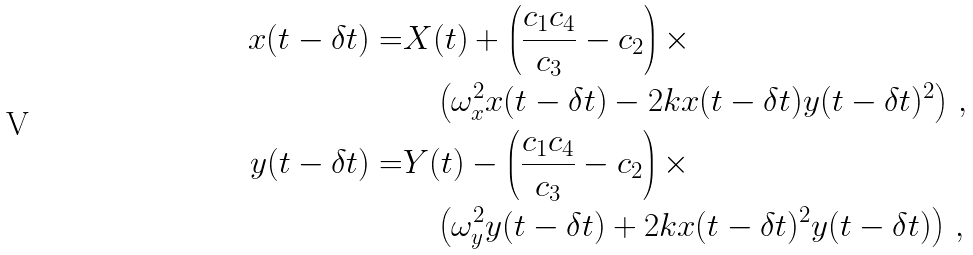<formula> <loc_0><loc_0><loc_500><loc_500>x ( t - \delta t ) = & X ( t ) + \left ( \frac { c _ { 1 } c _ { 4 } } { c _ { 3 } } - c _ { 2 } \right ) \times \\ & \quad \left ( \omega _ { x } ^ { 2 } x ( t - \delta t ) - 2 k x ( t - \delta t ) y ( t - \delta t ) ^ { 2 } \right ) \, , \\ y ( t - \delta t ) = & Y ( t ) - \left ( \frac { c _ { 1 } c _ { 4 } } { c _ { 3 } } - c _ { 2 } \right ) \times \\ & \quad \left ( \omega _ { y } ^ { 2 } y ( t - \delta t ) + 2 k x ( t - \delta t ) ^ { 2 } y ( t - \delta t ) \right ) \, ,</formula> 